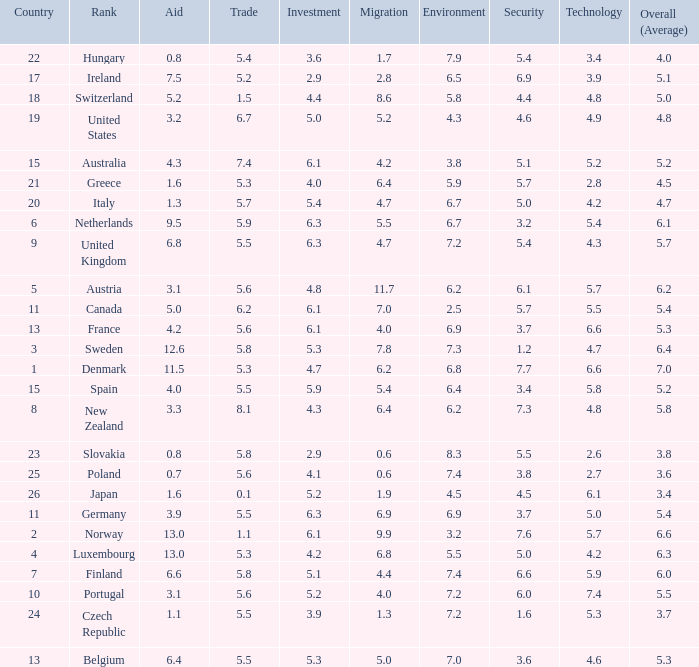What is the migration rating when trade is 5.7? 4.7. 